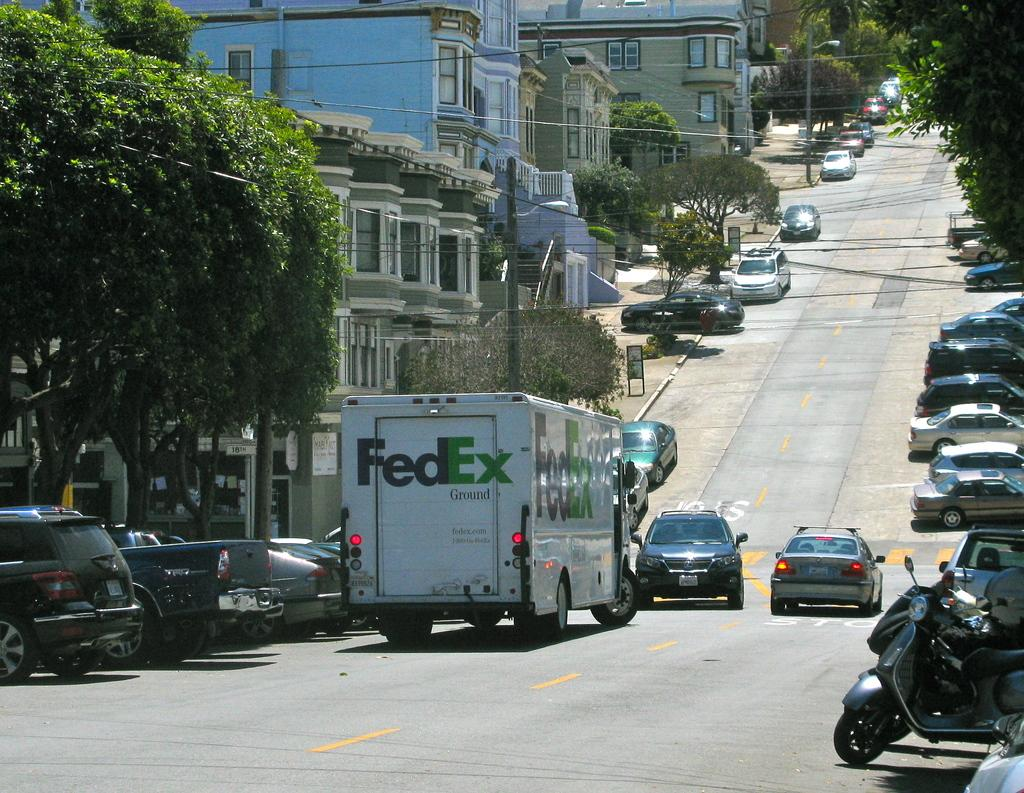What is happening on the road in the image? There are vehicles on the road in the image. What can be seen in the distance behind the vehicles? There are buildings, trees, and electric poles in the background of the image. Can you describe the unspecified objects in the background? Unfortunately, the facts do not specify the nature of these objects, so we cannot describe them. What type of cloud is present in the image? There is no cloud present in the image; the sky is not mentioned in the provided facts. How does the image promote peace? The image does not specifically promote peace; it simply shows vehicles on a road with buildings, trees, and electric poles in the background. 